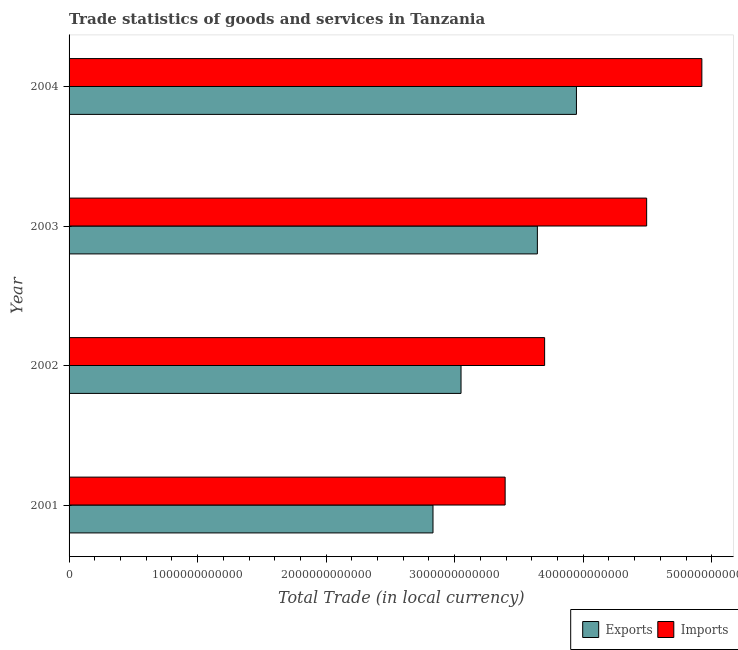How many different coloured bars are there?
Your answer should be compact. 2. Are the number of bars per tick equal to the number of legend labels?
Give a very brief answer. Yes. What is the imports of goods and services in 2004?
Give a very brief answer. 4.92e+12. Across all years, what is the maximum export of goods and services?
Your response must be concise. 3.95e+12. Across all years, what is the minimum export of goods and services?
Keep it short and to the point. 2.83e+12. In which year was the imports of goods and services minimum?
Offer a very short reply. 2001. What is the total imports of goods and services in the graph?
Provide a succinct answer. 1.65e+13. What is the difference between the imports of goods and services in 2003 and that in 2004?
Your answer should be compact. -4.29e+11. What is the difference between the export of goods and services in 2003 and the imports of goods and services in 2001?
Make the answer very short. 2.51e+11. What is the average imports of goods and services per year?
Keep it short and to the point. 4.13e+12. In the year 2003, what is the difference between the imports of goods and services and export of goods and services?
Offer a very short reply. 8.50e+11. What is the ratio of the export of goods and services in 2002 to that in 2004?
Offer a very short reply. 0.77. Is the imports of goods and services in 2002 less than that in 2004?
Give a very brief answer. Yes. Is the difference between the imports of goods and services in 2001 and 2004 greater than the difference between the export of goods and services in 2001 and 2004?
Provide a short and direct response. No. What is the difference between the highest and the second highest imports of goods and services?
Provide a short and direct response. 4.29e+11. What is the difference between the highest and the lowest export of goods and services?
Your response must be concise. 1.12e+12. What does the 1st bar from the top in 2001 represents?
Offer a very short reply. Imports. What does the 2nd bar from the bottom in 2003 represents?
Give a very brief answer. Imports. Are all the bars in the graph horizontal?
Make the answer very short. Yes. How many years are there in the graph?
Your answer should be compact. 4. What is the difference between two consecutive major ticks on the X-axis?
Ensure brevity in your answer.  1.00e+12. Does the graph contain any zero values?
Your response must be concise. No. Does the graph contain grids?
Keep it short and to the point. No. What is the title of the graph?
Make the answer very short. Trade statistics of goods and services in Tanzania. Does "Female population" appear as one of the legend labels in the graph?
Your answer should be very brief. No. What is the label or title of the X-axis?
Provide a succinct answer. Total Trade (in local currency). What is the Total Trade (in local currency) in Exports in 2001?
Offer a terse response. 2.83e+12. What is the Total Trade (in local currency) of Imports in 2001?
Your answer should be compact. 3.39e+12. What is the Total Trade (in local currency) of Exports in 2002?
Your response must be concise. 3.05e+12. What is the Total Trade (in local currency) of Imports in 2002?
Make the answer very short. 3.70e+12. What is the Total Trade (in local currency) of Exports in 2003?
Give a very brief answer. 3.64e+12. What is the Total Trade (in local currency) of Imports in 2003?
Offer a terse response. 4.49e+12. What is the Total Trade (in local currency) in Exports in 2004?
Ensure brevity in your answer.  3.95e+12. What is the Total Trade (in local currency) in Imports in 2004?
Ensure brevity in your answer.  4.92e+12. Across all years, what is the maximum Total Trade (in local currency) of Exports?
Your response must be concise. 3.95e+12. Across all years, what is the maximum Total Trade (in local currency) in Imports?
Give a very brief answer. 4.92e+12. Across all years, what is the minimum Total Trade (in local currency) in Exports?
Your answer should be compact. 2.83e+12. Across all years, what is the minimum Total Trade (in local currency) of Imports?
Your response must be concise. 3.39e+12. What is the total Total Trade (in local currency) of Exports in the graph?
Keep it short and to the point. 1.35e+13. What is the total Total Trade (in local currency) of Imports in the graph?
Ensure brevity in your answer.  1.65e+13. What is the difference between the Total Trade (in local currency) in Exports in 2001 and that in 2002?
Offer a very short reply. -2.18e+11. What is the difference between the Total Trade (in local currency) in Imports in 2001 and that in 2002?
Ensure brevity in your answer.  -3.07e+11. What is the difference between the Total Trade (in local currency) of Exports in 2001 and that in 2003?
Provide a succinct answer. -8.12e+11. What is the difference between the Total Trade (in local currency) in Imports in 2001 and that in 2003?
Your answer should be compact. -1.10e+12. What is the difference between the Total Trade (in local currency) in Exports in 2001 and that in 2004?
Provide a short and direct response. -1.12e+12. What is the difference between the Total Trade (in local currency) in Imports in 2001 and that in 2004?
Your answer should be compact. -1.53e+12. What is the difference between the Total Trade (in local currency) of Exports in 2002 and that in 2003?
Your answer should be very brief. -5.94e+11. What is the difference between the Total Trade (in local currency) of Imports in 2002 and that in 2003?
Your response must be concise. -7.94e+11. What is the difference between the Total Trade (in local currency) in Exports in 2002 and that in 2004?
Keep it short and to the point. -8.98e+11. What is the difference between the Total Trade (in local currency) in Imports in 2002 and that in 2004?
Ensure brevity in your answer.  -1.22e+12. What is the difference between the Total Trade (in local currency) in Exports in 2003 and that in 2004?
Give a very brief answer. -3.04e+11. What is the difference between the Total Trade (in local currency) of Imports in 2003 and that in 2004?
Provide a short and direct response. -4.29e+11. What is the difference between the Total Trade (in local currency) of Exports in 2001 and the Total Trade (in local currency) of Imports in 2002?
Your response must be concise. -8.68e+11. What is the difference between the Total Trade (in local currency) of Exports in 2001 and the Total Trade (in local currency) of Imports in 2003?
Provide a short and direct response. -1.66e+12. What is the difference between the Total Trade (in local currency) in Exports in 2001 and the Total Trade (in local currency) in Imports in 2004?
Ensure brevity in your answer.  -2.09e+12. What is the difference between the Total Trade (in local currency) of Exports in 2002 and the Total Trade (in local currency) of Imports in 2003?
Provide a succinct answer. -1.44e+12. What is the difference between the Total Trade (in local currency) in Exports in 2002 and the Total Trade (in local currency) in Imports in 2004?
Your response must be concise. -1.87e+12. What is the difference between the Total Trade (in local currency) of Exports in 2003 and the Total Trade (in local currency) of Imports in 2004?
Provide a short and direct response. -1.28e+12. What is the average Total Trade (in local currency) of Exports per year?
Offer a very short reply. 3.37e+12. What is the average Total Trade (in local currency) in Imports per year?
Your response must be concise. 4.13e+12. In the year 2001, what is the difference between the Total Trade (in local currency) of Exports and Total Trade (in local currency) of Imports?
Provide a short and direct response. -5.61e+11. In the year 2002, what is the difference between the Total Trade (in local currency) of Exports and Total Trade (in local currency) of Imports?
Make the answer very short. -6.50e+11. In the year 2003, what is the difference between the Total Trade (in local currency) of Exports and Total Trade (in local currency) of Imports?
Offer a very short reply. -8.50e+11. In the year 2004, what is the difference between the Total Trade (in local currency) in Exports and Total Trade (in local currency) in Imports?
Keep it short and to the point. -9.76e+11. What is the ratio of the Total Trade (in local currency) of Exports in 2001 to that in 2002?
Provide a short and direct response. 0.93. What is the ratio of the Total Trade (in local currency) of Imports in 2001 to that in 2002?
Your response must be concise. 0.92. What is the ratio of the Total Trade (in local currency) in Exports in 2001 to that in 2003?
Your response must be concise. 0.78. What is the ratio of the Total Trade (in local currency) in Imports in 2001 to that in 2003?
Your response must be concise. 0.76. What is the ratio of the Total Trade (in local currency) of Exports in 2001 to that in 2004?
Offer a very short reply. 0.72. What is the ratio of the Total Trade (in local currency) of Imports in 2001 to that in 2004?
Offer a terse response. 0.69. What is the ratio of the Total Trade (in local currency) of Exports in 2002 to that in 2003?
Ensure brevity in your answer.  0.84. What is the ratio of the Total Trade (in local currency) in Imports in 2002 to that in 2003?
Make the answer very short. 0.82. What is the ratio of the Total Trade (in local currency) of Exports in 2002 to that in 2004?
Provide a short and direct response. 0.77. What is the ratio of the Total Trade (in local currency) in Imports in 2002 to that in 2004?
Your answer should be compact. 0.75. What is the ratio of the Total Trade (in local currency) of Exports in 2003 to that in 2004?
Make the answer very short. 0.92. What is the ratio of the Total Trade (in local currency) of Imports in 2003 to that in 2004?
Offer a terse response. 0.91. What is the difference between the highest and the second highest Total Trade (in local currency) of Exports?
Ensure brevity in your answer.  3.04e+11. What is the difference between the highest and the second highest Total Trade (in local currency) of Imports?
Your response must be concise. 4.29e+11. What is the difference between the highest and the lowest Total Trade (in local currency) in Exports?
Provide a succinct answer. 1.12e+12. What is the difference between the highest and the lowest Total Trade (in local currency) in Imports?
Ensure brevity in your answer.  1.53e+12. 